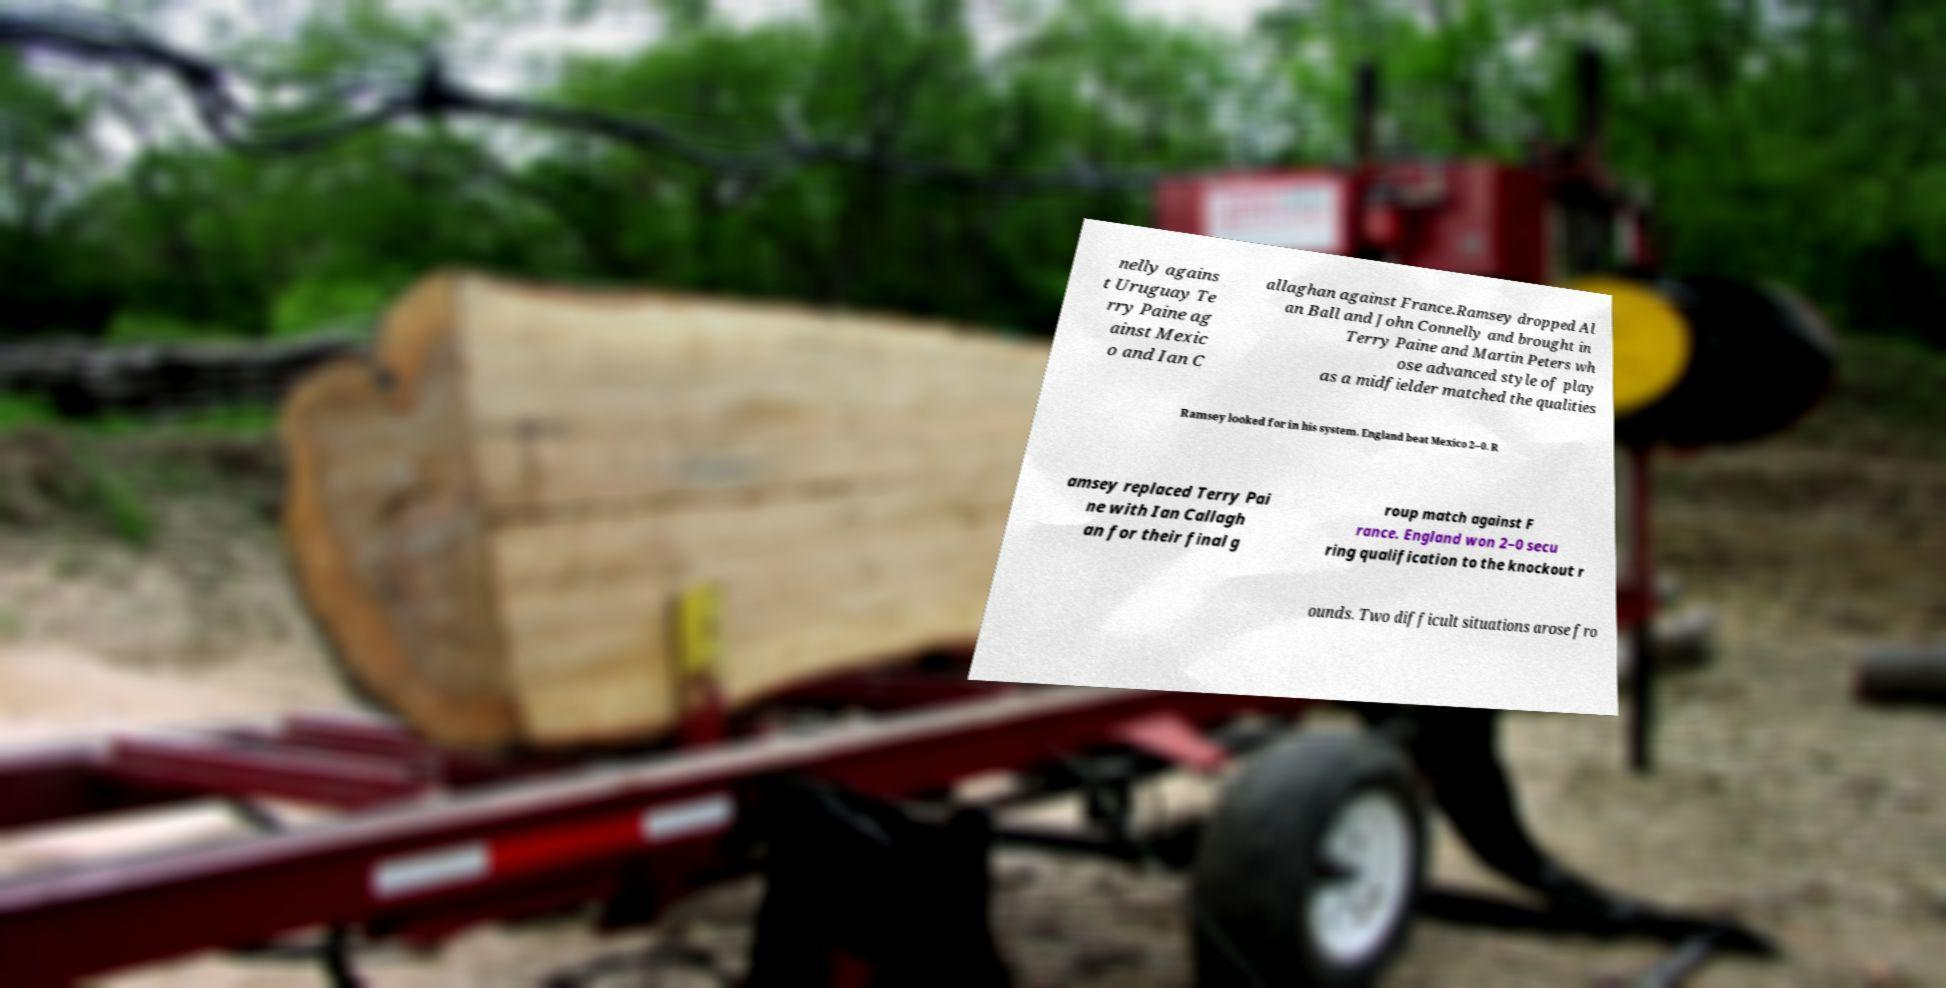Please read and relay the text visible in this image. What does it say? nelly agains t Uruguay Te rry Paine ag ainst Mexic o and Ian C allaghan against France.Ramsey dropped Al an Ball and John Connelly and brought in Terry Paine and Martin Peters wh ose advanced style of play as a midfielder matched the qualities Ramsey looked for in his system. England beat Mexico 2–0. R amsey replaced Terry Pai ne with Ian Callagh an for their final g roup match against F rance. England won 2–0 secu ring qualification to the knockout r ounds. Two difficult situations arose fro 